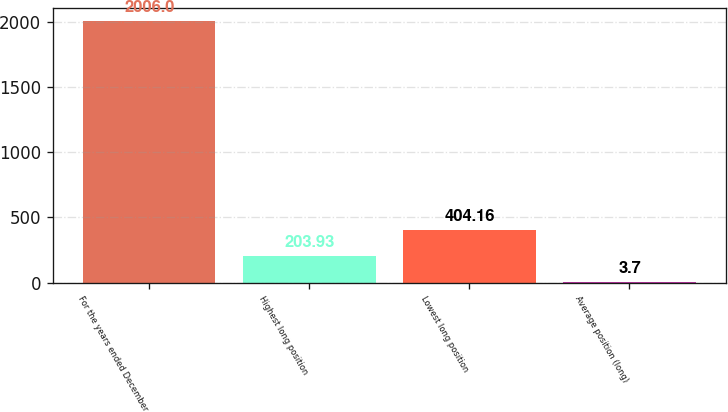Convert chart to OTSL. <chart><loc_0><loc_0><loc_500><loc_500><bar_chart><fcel>For the years ended December<fcel>Highest long position<fcel>Lowest long position<fcel>Average position (long)<nl><fcel>2006<fcel>203.93<fcel>404.16<fcel>3.7<nl></chart> 